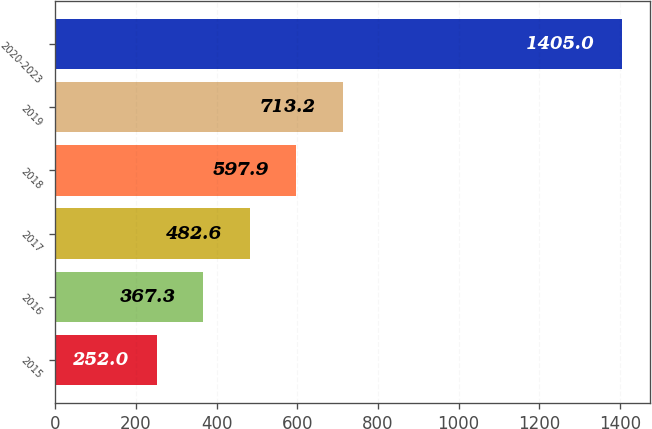<chart> <loc_0><loc_0><loc_500><loc_500><bar_chart><fcel>2015<fcel>2016<fcel>2017<fcel>2018<fcel>2019<fcel>2020-2023<nl><fcel>252<fcel>367.3<fcel>482.6<fcel>597.9<fcel>713.2<fcel>1405<nl></chart> 